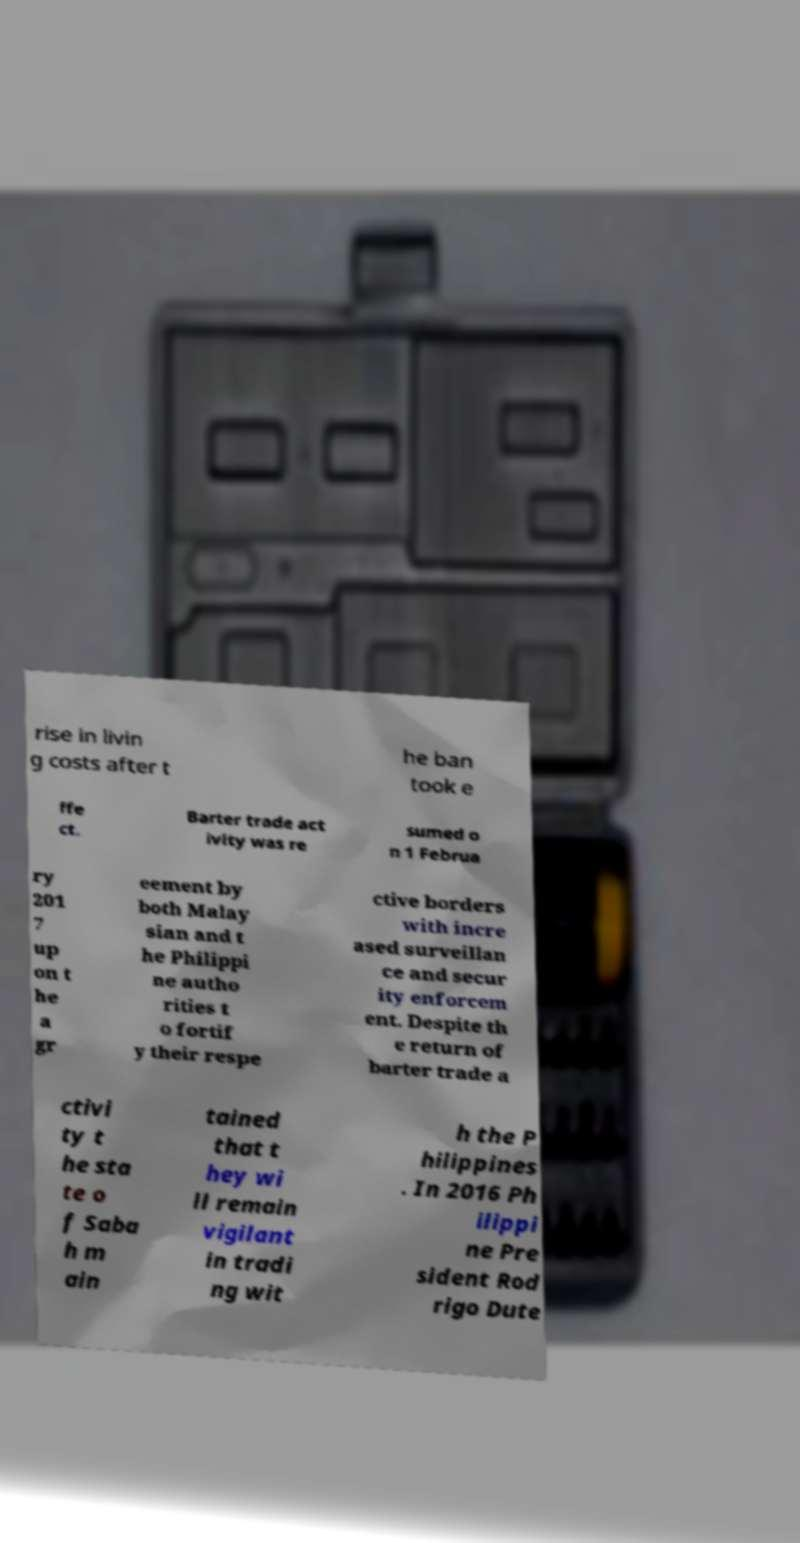Please identify and transcribe the text found in this image. rise in livin g costs after t he ban took e ffe ct. Barter trade act ivity was re sumed o n 1 Februa ry 201 7 up on t he a gr eement by both Malay sian and t he Philippi ne autho rities t o fortif y their respe ctive borders with incre ased surveillan ce and secur ity enforcem ent. Despite th e return of barter trade a ctivi ty t he sta te o f Saba h m ain tained that t hey wi ll remain vigilant in tradi ng wit h the P hilippines . In 2016 Ph ilippi ne Pre sident Rod rigo Dute 